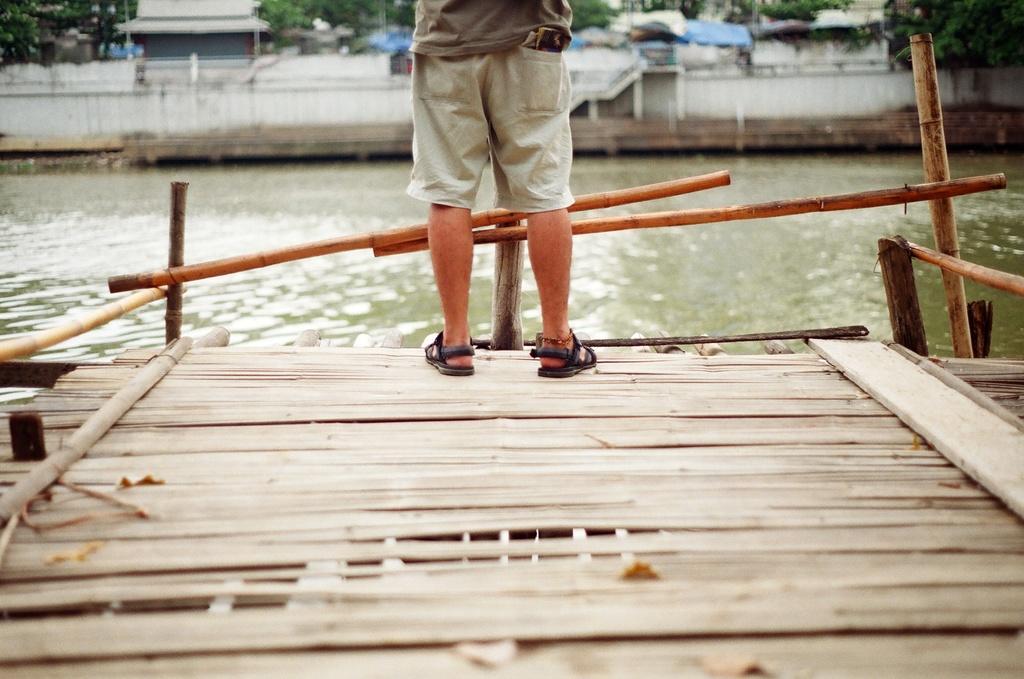Please provide a concise description of this image. In this picture we can see a person standing on the platform and in the background we can see water, few sheds and trees. 